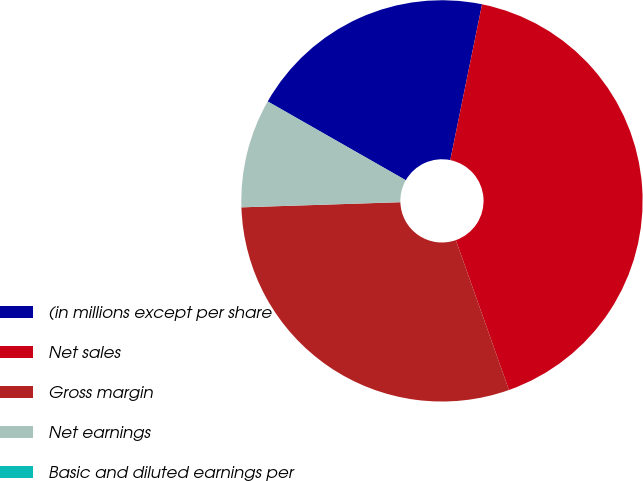Convert chart to OTSL. <chart><loc_0><loc_0><loc_500><loc_500><pie_chart><fcel>(in millions except per share<fcel>Net sales<fcel>Gross margin<fcel>Net earnings<fcel>Basic and diluted earnings per<nl><fcel>19.95%<fcel>41.38%<fcel>29.91%<fcel>8.76%<fcel>0.01%<nl></chart> 